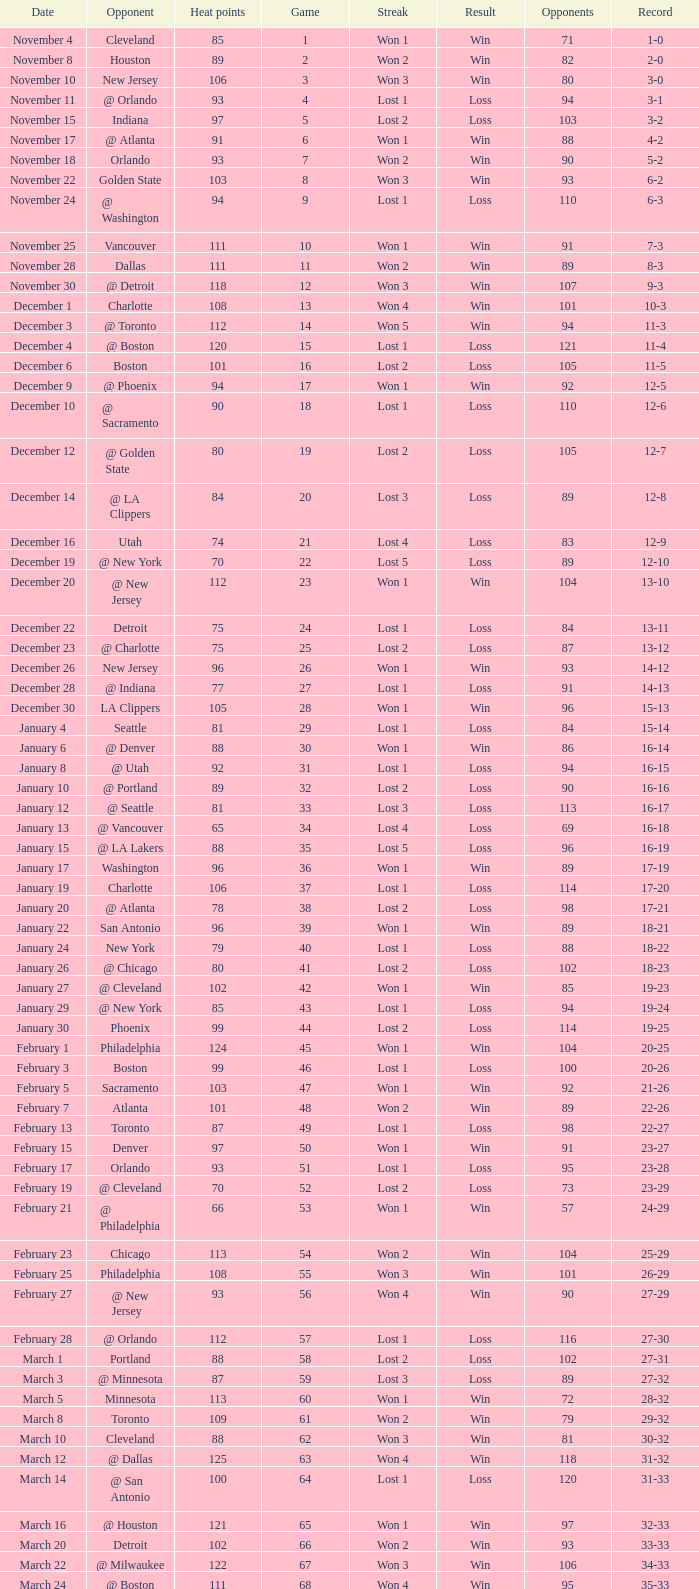What is the average Heat Points, when Result is "Loss", when Game is greater than 72, and when Date is "April 21"? 92.0. 